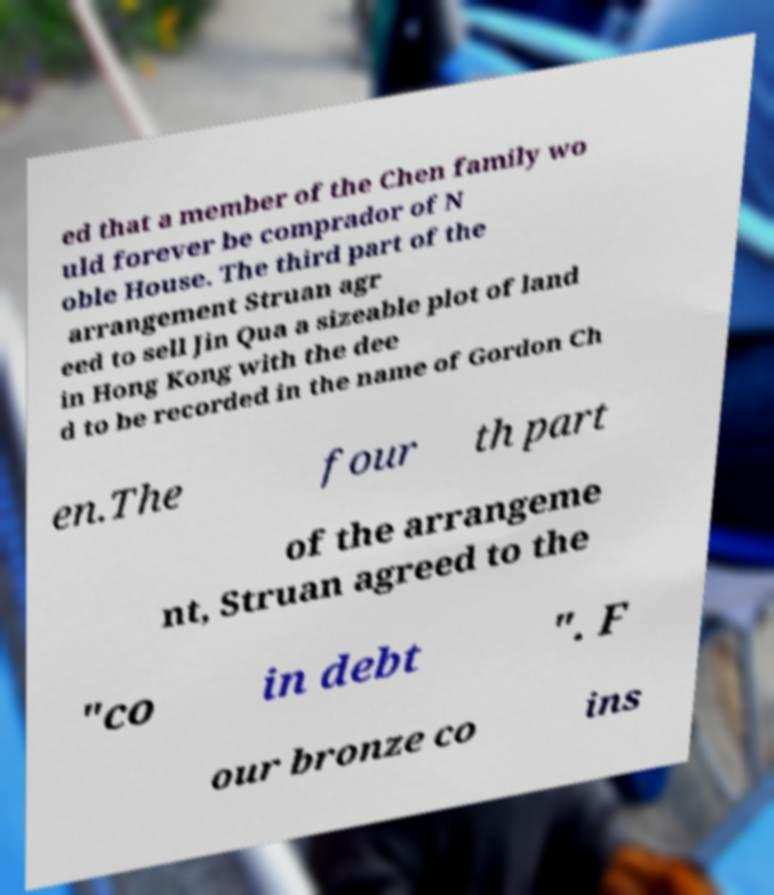Please read and relay the text visible in this image. What does it say? ed that a member of the Chen family wo uld forever be comprador of N oble House. The third part of the arrangement Struan agr eed to sell Jin Qua a sizeable plot of land in Hong Kong with the dee d to be recorded in the name of Gordon Ch en.The four th part of the arrangeme nt, Struan agreed to the "co in debt ". F our bronze co ins 